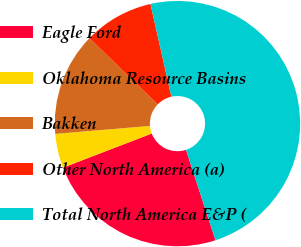Convert chart to OTSL. <chart><loc_0><loc_0><loc_500><loc_500><pie_chart><fcel>Eagle Ford<fcel>Oklahoma Resource Basins<fcel>Bakken<fcel>Other North America (a)<fcel>Total North America E&P (<nl><fcel>24.17%<fcel>4.51%<fcel>13.6%<fcel>9.2%<fcel>48.52%<nl></chart> 